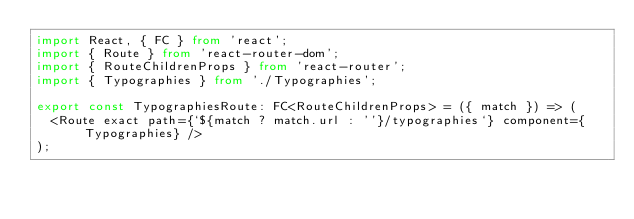Convert code to text. <code><loc_0><loc_0><loc_500><loc_500><_TypeScript_>import React, { FC } from 'react';
import { Route } from 'react-router-dom';
import { RouteChildrenProps } from 'react-router';
import { Typographies } from './Typographies';

export const TypographiesRoute: FC<RouteChildrenProps> = ({ match }) => (
  <Route exact path={`${match ? match.url : ''}/typographies`} component={Typographies} />
);
</code> 